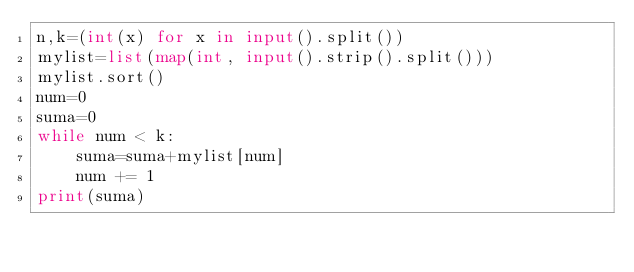Convert code to text. <code><loc_0><loc_0><loc_500><loc_500><_Python_>n,k=(int(x) for x in input().split())
mylist=list(map(int, input().strip().split()))
mylist.sort()
num=0
suma=0
while num < k:
    suma=suma+mylist[num]
    num += 1
print(suma)</code> 